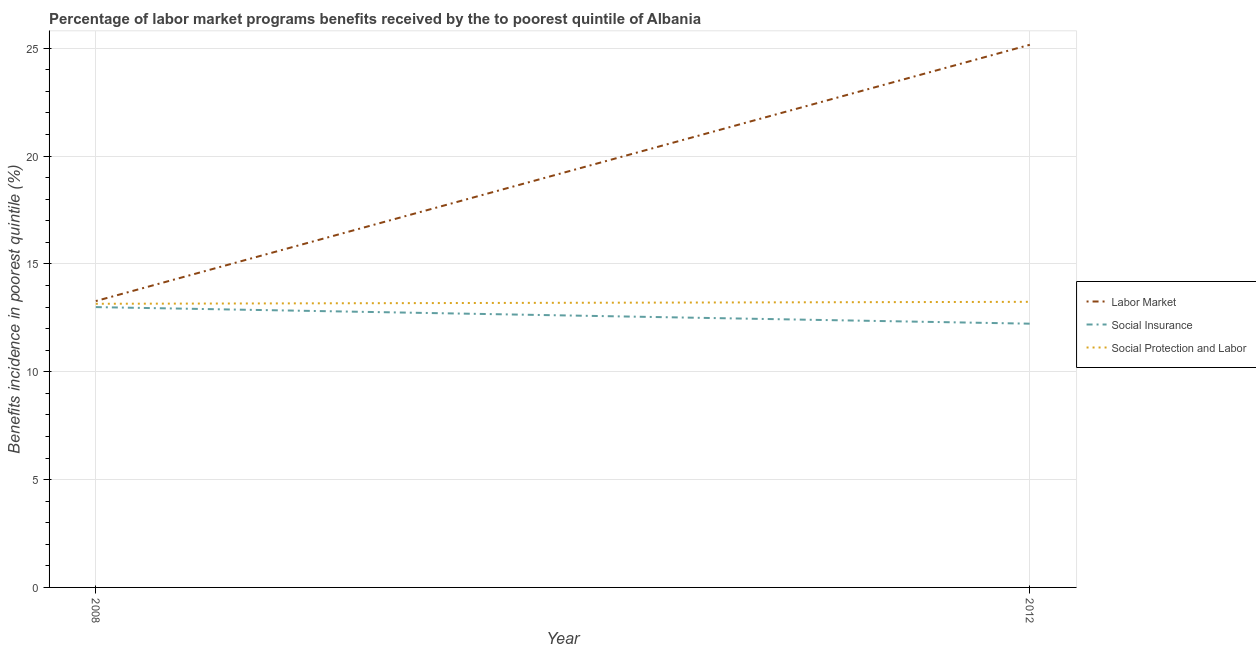Does the line corresponding to percentage of benefits received due to social insurance programs intersect with the line corresponding to percentage of benefits received due to social protection programs?
Ensure brevity in your answer.  No. Is the number of lines equal to the number of legend labels?
Ensure brevity in your answer.  Yes. What is the percentage of benefits received due to social protection programs in 2012?
Keep it short and to the point. 13.24. Across all years, what is the maximum percentage of benefits received due to social insurance programs?
Your answer should be very brief. 13. Across all years, what is the minimum percentage of benefits received due to social insurance programs?
Provide a short and direct response. 12.23. What is the total percentage of benefits received due to labor market programs in the graph?
Offer a terse response. 38.44. What is the difference between the percentage of benefits received due to social insurance programs in 2008 and that in 2012?
Offer a very short reply. 0.77. What is the difference between the percentage of benefits received due to labor market programs in 2012 and the percentage of benefits received due to social protection programs in 2008?
Make the answer very short. 12.01. What is the average percentage of benefits received due to social insurance programs per year?
Keep it short and to the point. 12.61. In the year 2012, what is the difference between the percentage of benefits received due to social protection programs and percentage of benefits received due to social insurance programs?
Provide a succinct answer. 1.01. What is the ratio of the percentage of benefits received due to labor market programs in 2008 to that in 2012?
Offer a very short reply. 0.53. Is it the case that in every year, the sum of the percentage of benefits received due to labor market programs and percentage of benefits received due to social insurance programs is greater than the percentage of benefits received due to social protection programs?
Ensure brevity in your answer.  Yes. Is the percentage of benefits received due to social protection programs strictly greater than the percentage of benefits received due to labor market programs over the years?
Offer a terse response. No. How many lines are there?
Offer a terse response. 3. How many years are there in the graph?
Your answer should be very brief. 2. What is the difference between two consecutive major ticks on the Y-axis?
Offer a very short reply. 5. Are the values on the major ticks of Y-axis written in scientific E-notation?
Your answer should be compact. No. Does the graph contain any zero values?
Your response must be concise. No. Does the graph contain grids?
Keep it short and to the point. Yes. How many legend labels are there?
Give a very brief answer. 3. How are the legend labels stacked?
Give a very brief answer. Vertical. What is the title of the graph?
Provide a succinct answer. Percentage of labor market programs benefits received by the to poorest quintile of Albania. What is the label or title of the X-axis?
Offer a very short reply. Year. What is the label or title of the Y-axis?
Offer a very short reply. Benefits incidence in poorest quintile (%). What is the Benefits incidence in poorest quintile (%) in Labor Market in 2008?
Provide a succinct answer. 13.28. What is the Benefits incidence in poorest quintile (%) in Social Insurance in 2008?
Give a very brief answer. 13. What is the Benefits incidence in poorest quintile (%) in Social Protection and Labor in 2008?
Ensure brevity in your answer.  13.15. What is the Benefits incidence in poorest quintile (%) in Labor Market in 2012?
Your answer should be very brief. 25.16. What is the Benefits incidence in poorest quintile (%) of Social Insurance in 2012?
Provide a succinct answer. 12.23. What is the Benefits incidence in poorest quintile (%) of Social Protection and Labor in 2012?
Give a very brief answer. 13.24. Across all years, what is the maximum Benefits incidence in poorest quintile (%) in Labor Market?
Ensure brevity in your answer.  25.16. Across all years, what is the maximum Benefits incidence in poorest quintile (%) of Social Insurance?
Your response must be concise. 13. Across all years, what is the maximum Benefits incidence in poorest quintile (%) of Social Protection and Labor?
Offer a very short reply. 13.24. Across all years, what is the minimum Benefits incidence in poorest quintile (%) in Labor Market?
Your answer should be compact. 13.28. Across all years, what is the minimum Benefits incidence in poorest quintile (%) in Social Insurance?
Provide a short and direct response. 12.23. Across all years, what is the minimum Benefits incidence in poorest quintile (%) in Social Protection and Labor?
Keep it short and to the point. 13.15. What is the total Benefits incidence in poorest quintile (%) in Labor Market in the graph?
Provide a short and direct response. 38.44. What is the total Benefits incidence in poorest quintile (%) of Social Insurance in the graph?
Offer a terse response. 25.22. What is the total Benefits incidence in poorest quintile (%) in Social Protection and Labor in the graph?
Make the answer very short. 26.39. What is the difference between the Benefits incidence in poorest quintile (%) in Labor Market in 2008 and that in 2012?
Ensure brevity in your answer.  -11.88. What is the difference between the Benefits incidence in poorest quintile (%) in Social Insurance in 2008 and that in 2012?
Your answer should be compact. 0.77. What is the difference between the Benefits incidence in poorest quintile (%) of Social Protection and Labor in 2008 and that in 2012?
Your response must be concise. -0.09. What is the difference between the Benefits incidence in poorest quintile (%) in Labor Market in 2008 and the Benefits incidence in poorest quintile (%) in Social Insurance in 2012?
Offer a terse response. 1.05. What is the difference between the Benefits incidence in poorest quintile (%) of Labor Market in 2008 and the Benefits incidence in poorest quintile (%) of Social Protection and Labor in 2012?
Offer a very short reply. 0.04. What is the difference between the Benefits incidence in poorest quintile (%) of Social Insurance in 2008 and the Benefits incidence in poorest quintile (%) of Social Protection and Labor in 2012?
Provide a succinct answer. -0.24. What is the average Benefits incidence in poorest quintile (%) in Labor Market per year?
Your answer should be very brief. 19.22. What is the average Benefits incidence in poorest quintile (%) in Social Insurance per year?
Keep it short and to the point. 12.61. What is the average Benefits incidence in poorest quintile (%) in Social Protection and Labor per year?
Offer a terse response. 13.2. In the year 2008, what is the difference between the Benefits incidence in poorest quintile (%) of Labor Market and Benefits incidence in poorest quintile (%) of Social Insurance?
Your response must be concise. 0.28. In the year 2008, what is the difference between the Benefits incidence in poorest quintile (%) in Labor Market and Benefits incidence in poorest quintile (%) in Social Protection and Labor?
Make the answer very short. 0.13. In the year 2008, what is the difference between the Benefits incidence in poorest quintile (%) in Social Insurance and Benefits incidence in poorest quintile (%) in Social Protection and Labor?
Ensure brevity in your answer.  -0.15. In the year 2012, what is the difference between the Benefits incidence in poorest quintile (%) of Labor Market and Benefits incidence in poorest quintile (%) of Social Insurance?
Give a very brief answer. 12.93. In the year 2012, what is the difference between the Benefits incidence in poorest quintile (%) in Labor Market and Benefits incidence in poorest quintile (%) in Social Protection and Labor?
Offer a very short reply. 11.92. In the year 2012, what is the difference between the Benefits incidence in poorest quintile (%) of Social Insurance and Benefits incidence in poorest quintile (%) of Social Protection and Labor?
Provide a short and direct response. -1.01. What is the ratio of the Benefits incidence in poorest quintile (%) of Labor Market in 2008 to that in 2012?
Offer a terse response. 0.53. What is the ratio of the Benefits incidence in poorest quintile (%) in Social Insurance in 2008 to that in 2012?
Offer a very short reply. 1.06. What is the difference between the highest and the second highest Benefits incidence in poorest quintile (%) in Labor Market?
Your answer should be very brief. 11.88. What is the difference between the highest and the second highest Benefits incidence in poorest quintile (%) in Social Insurance?
Your answer should be compact. 0.77. What is the difference between the highest and the second highest Benefits incidence in poorest quintile (%) of Social Protection and Labor?
Provide a succinct answer. 0.09. What is the difference between the highest and the lowest Benefits incidence in poorest quintile (%) of Labor Market?
Provide a short and direct response. 11.88. What is the difference between the highest and the lowest Benefits incidence in poorest quintile (%) in Social Insurance?
Your answer should be compact. 0.77. What is the difference between the highest and the lowest Benefits incidence in poorest quintile (%) of Social Protection and Labor?
Provide a succinct answer. 0.09. 